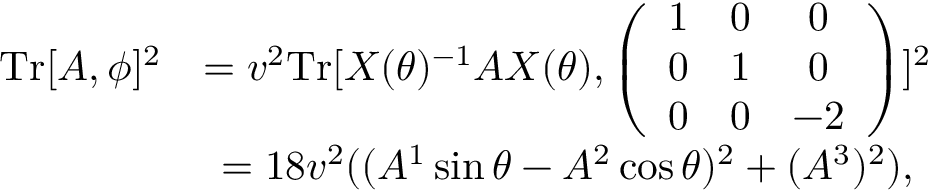Convert formula to latex. <formula><loc_0><loc_0><loc_500><loc_500>\begin{array} { c c } { { T r [ A , \phi ] ^ { 2 } } } & { { = v ^ { 2 } T r [ X ( \theta ) ^ { - 1 } A X ( \theta ) , \left ( \begin{array} { c c c } { 1 } & { 0 } & { 0 } \\ { 0 } & { 1 } & { 0 } \\ { 0 } & { 0 } & { - 2 } \end{array} \right ) ] ^ { 2 } } } & { { = 1 8 v ^ { 2 } ( ( A ^ { 1 } \sin \theta - A ^ { 2 } \cos \theta ) ^ { 2 } + ( A ^ { 3 } ) ^ { 2 } ) , } } \end{array}</formula> 